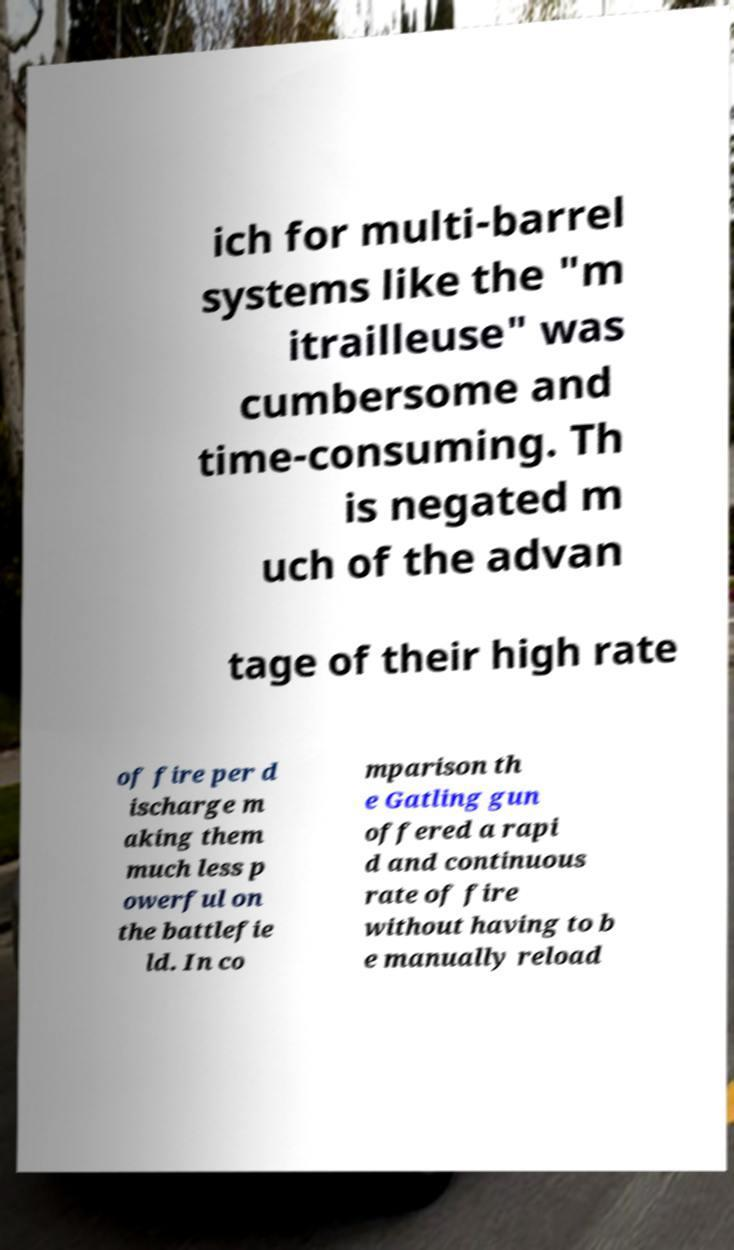There's text embedded in this image that I need extracted. Can you transcribe it verbatim? ich for multi-barrel systems like the "m itrailleuse" was cumbersome and time-consuming. Th is negated m uch of the advan tage of their high rate of fire per d ischarge m aking them much less p owerful on the battlefie ld. In co mparison th e Gatling gun offered a rapi d and continuous rate of fire without having to b e manually reload 